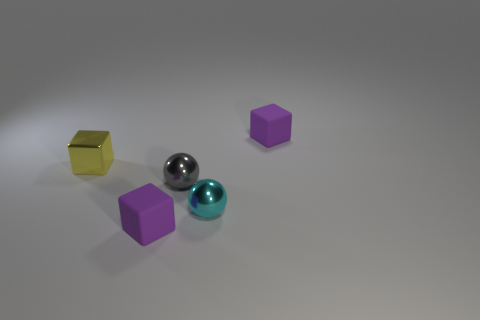Could you describe the composition of the objects and their spatial relationship? Certainly, the composition includes a small metallic object, two small cyan spheres, two purple cubes, and a yellow block. The metallic object is centered between the two cyan spheres, creating a visually balanced arrangement. The purple cubes are scattered more randomly, while the yellow block is placed distinctly apart, creating a sense of asymmetry. Collectively, the placement of these objects suggests careful arrangement with attention to both balance and contrast. 